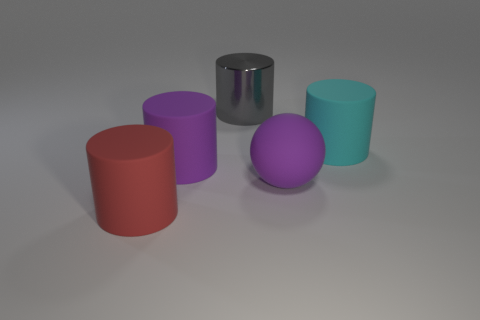What color is the rubber thing that is to the left of the purple rubber thing to the left of the purple matte ball? In the image, the rubber object to the left of the purple rubber cylinder, which in turn is to the left of the purple matte ball, appears to be red. The cylindrical shape and matte finish help differentiate it from the other objects in the scene. 